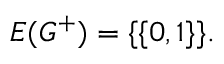Convert formula to latex. <formula><loc_0><loc_0><loc_500><loc_500>E ( G ^ { + } ) = \{ \{ 0 , 1 \} \} .</formula> 